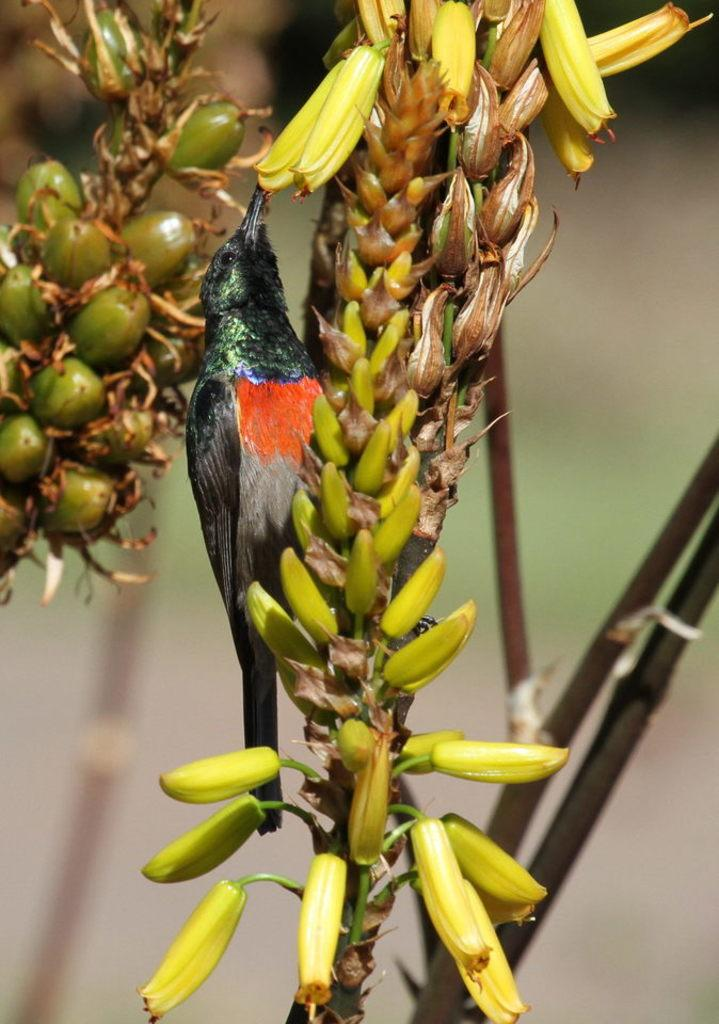What type of animal is on the plant in the image? There is a bird on a plant in the image. What else can be seen on the plant in the image? There are fruits on the plant in the image. What can be seen in the background of the image? There are poles in the background of the image. What year is depicted in the image? There is no specific year depicted in the image; it is a photograph of a bird, fruits, and poles. How many crows are present in the image? There are no crows present in the image; it features a bird, which is not a crow. 